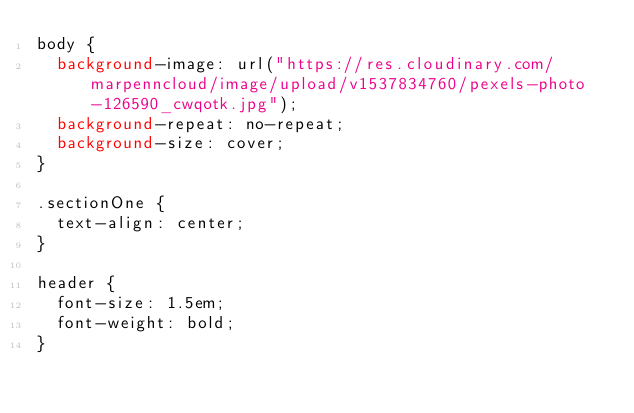Convert code to text. <code><loc_0><loc_0><loc_500><loc_500><_CSS_>body {
  background-image: url("https://res.cloudinary.com/marpenncloud/image/upload/v1537834760/pexels-photo-126590_cwqotk.jpg");
  background-repeat: no-repeat;
  background-size: cover;  
}

.sectionOne {
  text-align: center;
}

header {
  font-size: 1.5em;
  font-weight: bold;
}

</code> 